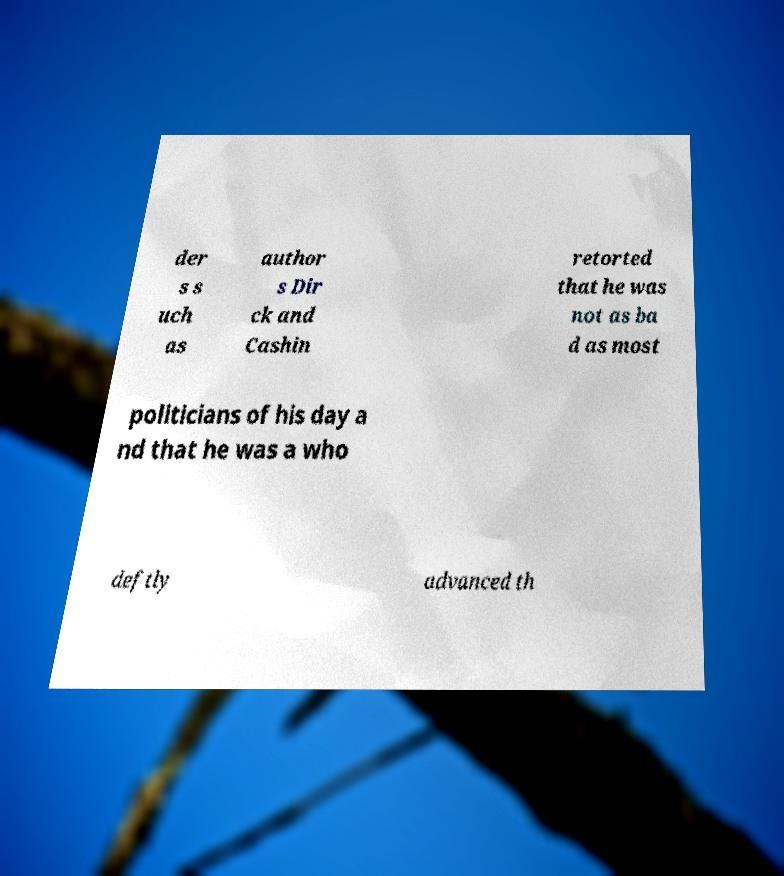What messages or text are displayed in this image? I need them in a readable, typed format. der s s uch as author s Dir ck and Cashin retorted that he was not as ba d as most politicians of his day a nd that he was a who deftly advanced th 